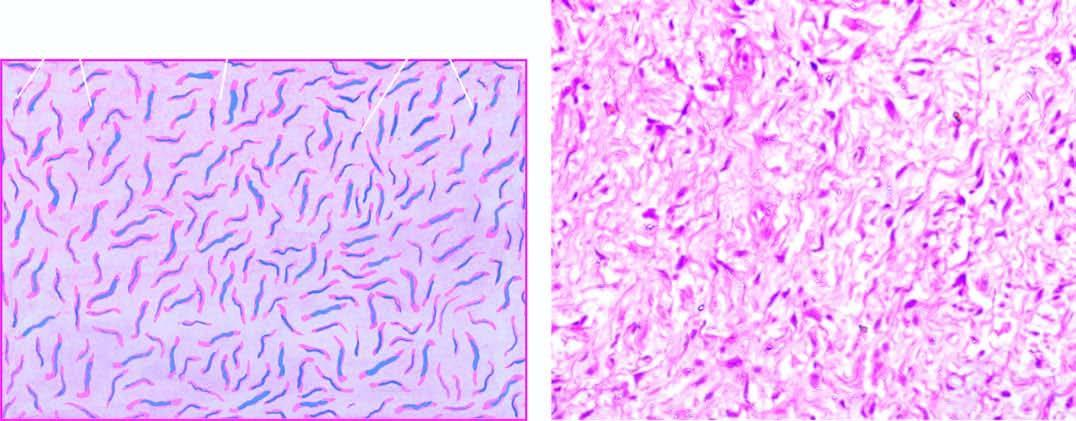what is also identified?
Answer the question using a single word or phrase. Cells have wavy nuclei and a residual nerve fibre 